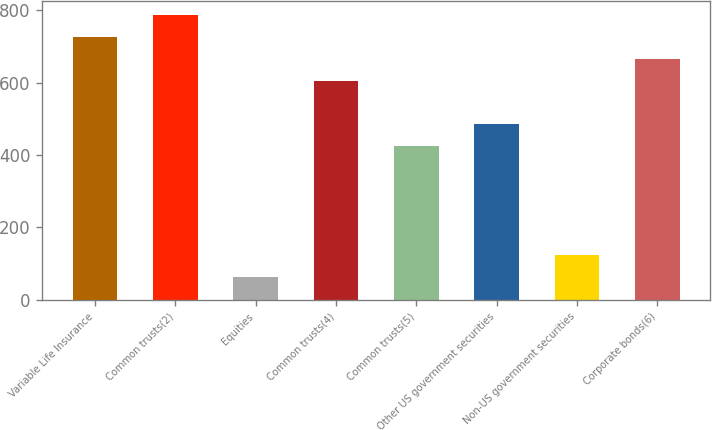<chart> <loc_0><loc_0><loc_500><loc_500><bar_chart><fcel>Variable Life Insurance<fcel>Common trusts(2)<fcel>Equities<fcel>Common trusts(4)<fcel>Common trusts(5)<fcel>Other US government securities<fcel>Non-US government securities<fcel>Corporate bonds(6)<nl><fcel>725.71<fcel>786.08<fcel>61.64<fcel>604.97<fcel>423.86<fcel>484.23<fcel>122.01<fcel>665.34<nl></chart> 